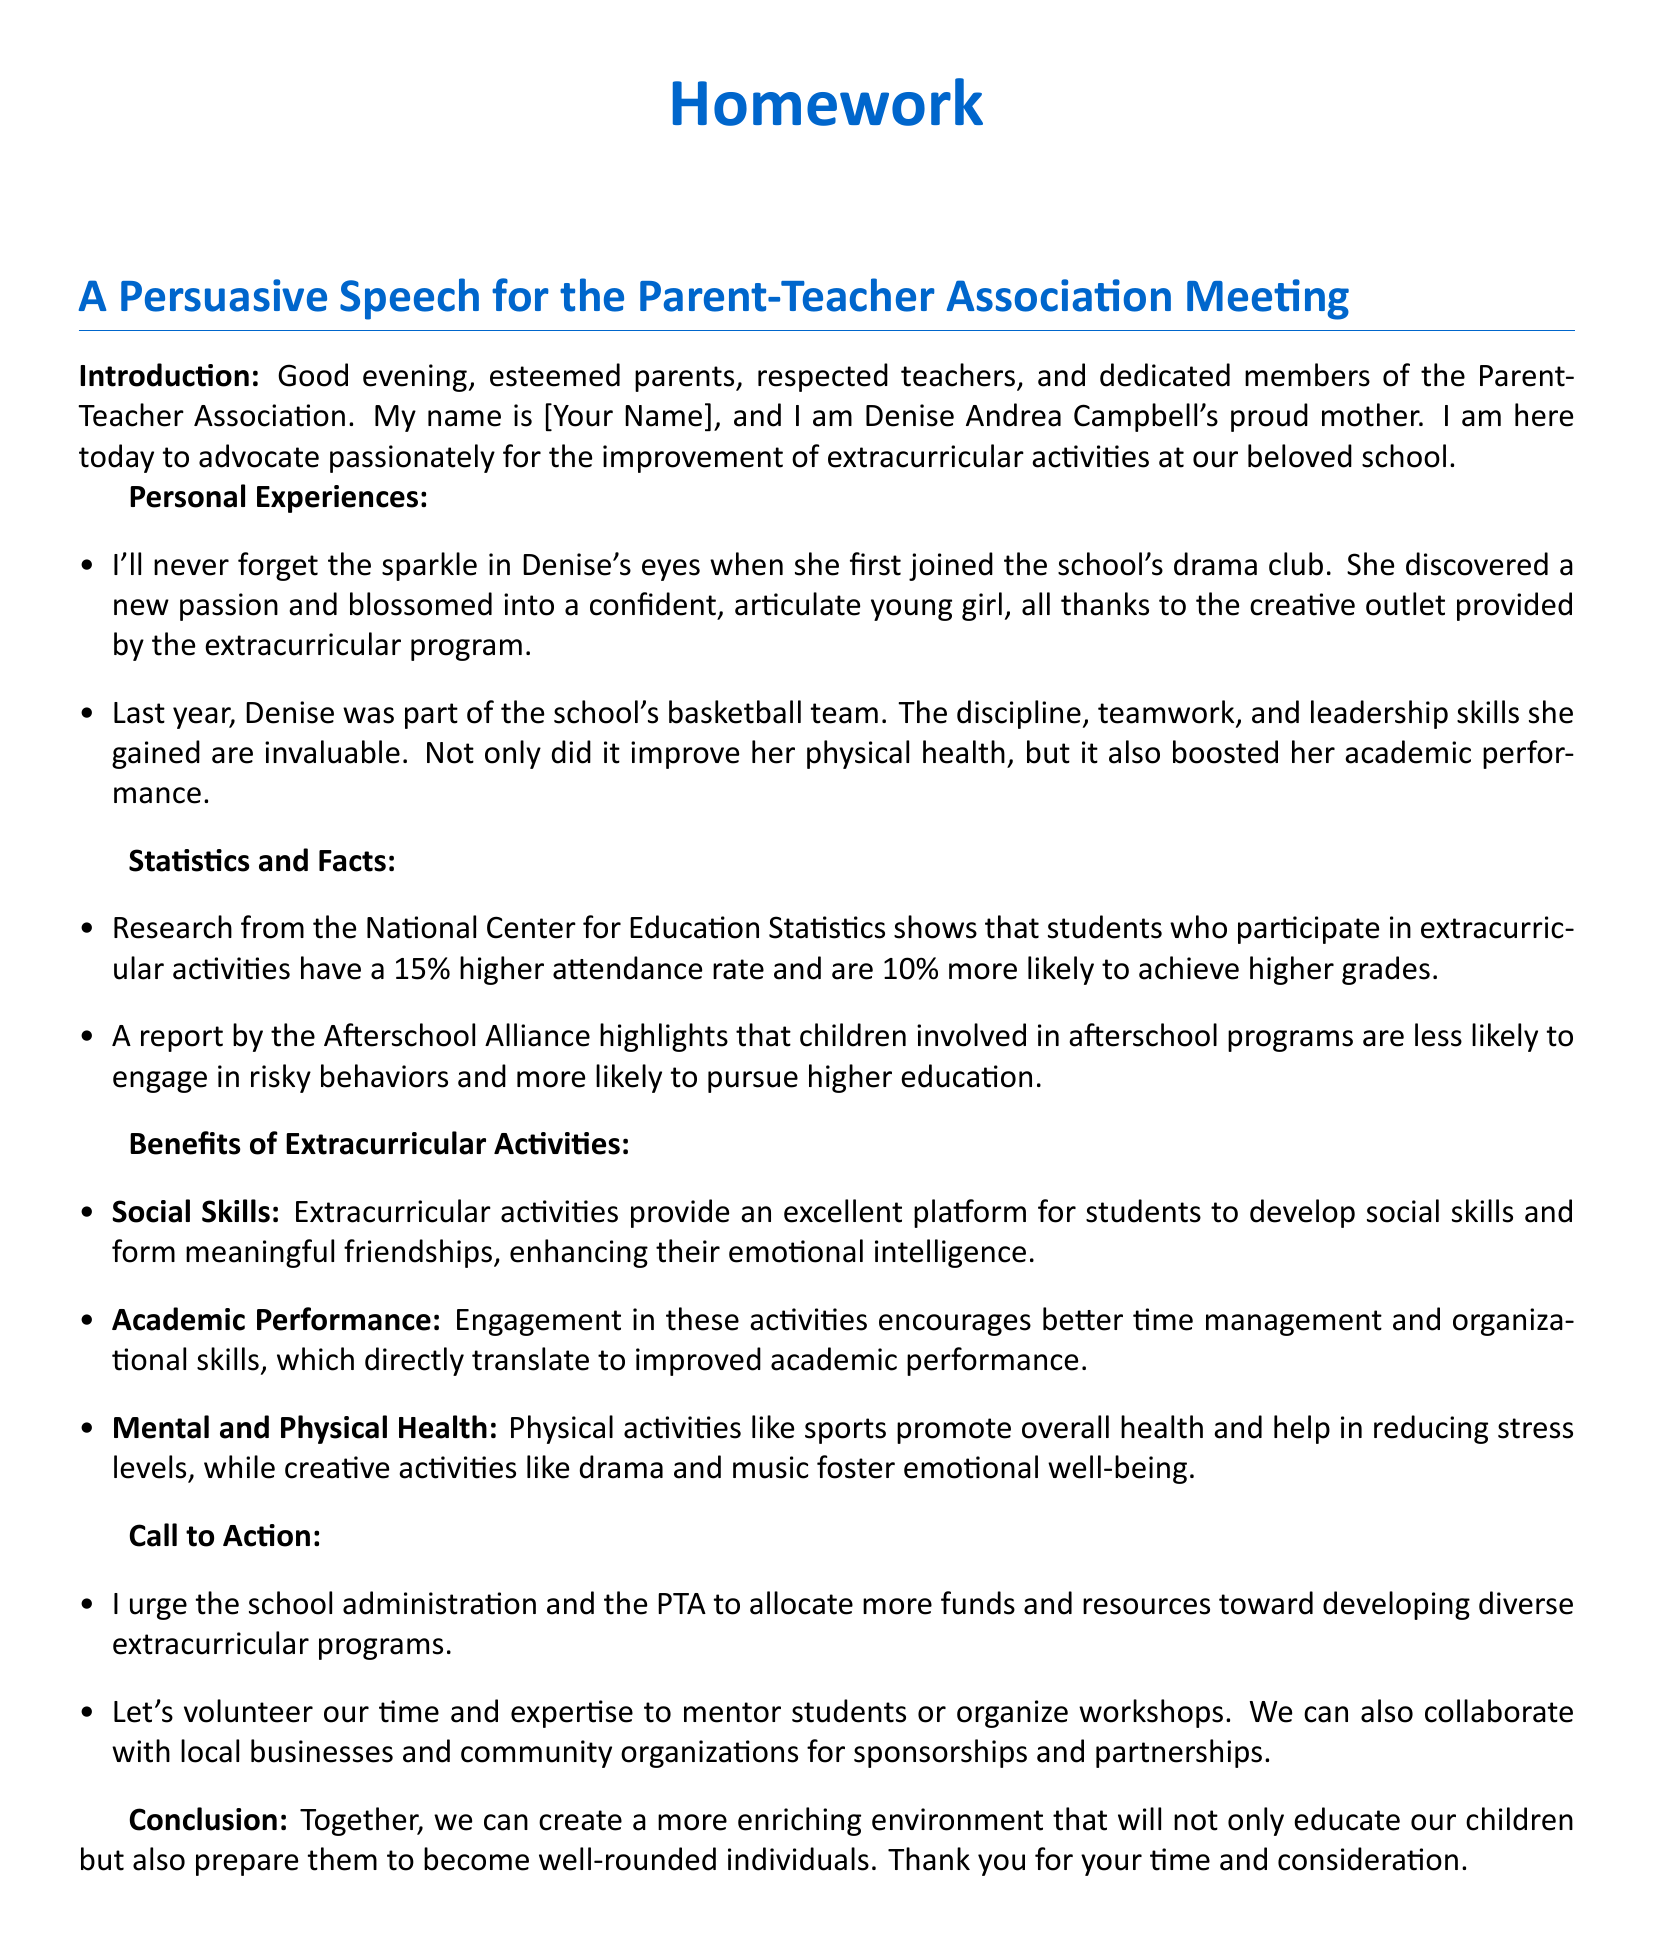What is the name of the speaker? The speaker introduces herself as Denise Andrea Campbell's proud mother.
Answer: Denise Andrea Campbell's proud mother What activity did Denise first join that made her blossom? The document states that Denise joined the school's drama club, which helped her develop confidence.
Answer: drama club What percentage higher attendance rate is reported for students participating in extracurricular activities? The document cites a 15% higher attendance rate for students who participate in extracurricular activities according to a research source.
Answer: 15% What type of skills did Denise gain from being part of the basketball team? The section on personal experiences mentions that Denise gained discipline, teamwork, and leadership skills from playing basketball.
Answer: discipline, teamwork, leadership What report highlights that children in afterschool programs are less likely to engage in risky behaviors? The document refers to a report by the Afterschool Alliance which discusses the benefits of afterschool programs.
Answer: Afterschool Alliance What is one benefit of extracurricular activities related to social skills? The benefits of extracurricular activities state they provide a platform for developing social skills and friendships.
Answer: develop social skills What is the call to action regarding school administration funds? The document urges the school administration and the PTA to allocate more funds toward extracurricular programs.
Answer: allocate more funds What kind of activities promote overall health according to the document? Physical activities like sports are mentioned as promoting overall health.
Answer: sports How does the document conclude its message? The conclusion calls for creating a more enriching environment for children and expresses gratitude.
Answer: create a more enriching environment 